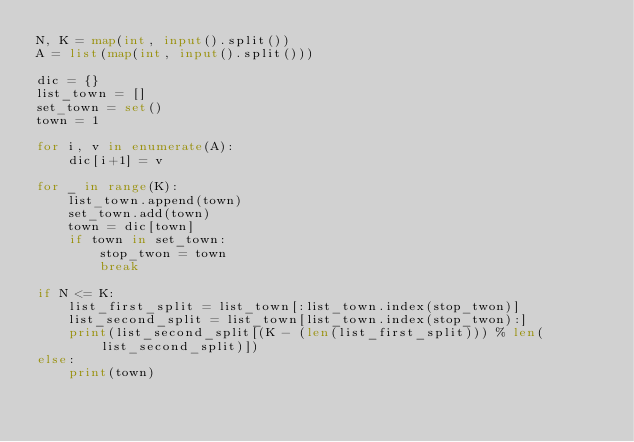Convert code to text. <code><loc_0><loc_0><loc_500><loc_500><_Python_>N, K = map(int, input().split())
A = list(map(int, input().split()))

dic = {}
list_town = []
set_town = set()
town = 1

for i, v in enumerate(A):
    dic[i+1] = v

for _ in range(K):
    list_town.append(town)
    set_town.add(town)
    town = dic[town]
    if town in set_town:
        stop_twon = town
        break

if N <= K:
    list_first_split = list_town[:list_town.index(stop_twon)]
    list_second_split = list_town[list_town.index(stop_twon):]
    print(list_second_split[(K - (len(list_first_split))) % len(list_second_split)])
else:
    print(town)</code> 